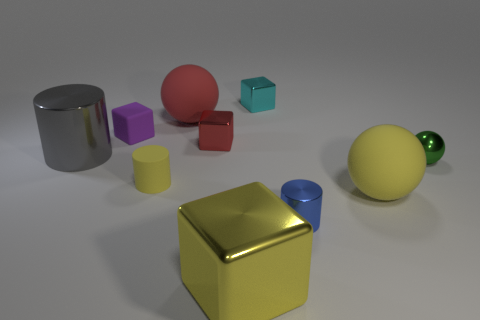What number of blocks are either small rubber objects or yellow things?
Provide a succinct answer. 2. What is the color of the ball that is made of the same material as the big gray cylinder?
Keep it short and to the point. Green. Are there fewer red metallic blocks than large green matte things?
Keep it short and to the point. No. There is a large matte object behind the metal ball; does it have the same shape as the yellow matte object behind the large yellow sphere?
Keep it short and to the point. No. What number of objects are either blue metallic cylinders or metal spheres?
Keep it short and to the point. 2. There is a cylinder that is the same size as the red sphere; what color is it?
Offer a very short reply. Gray. What number of big gray things are in front of the yellow object that is to the right of the small metallic cylinder?
Provide a succinct answer. 0. How many rubber objects are behind the tiny red metallic thing and on the right side of the small yellow matte thing?
Offer a very short reply. 1. What number of things are either rubber objects right of the purple rubber object or objects behind the big block?
Offer a terse response. 9. What number of other objects are the same size as the yellow metal object?
Offer a terse response. 3. 